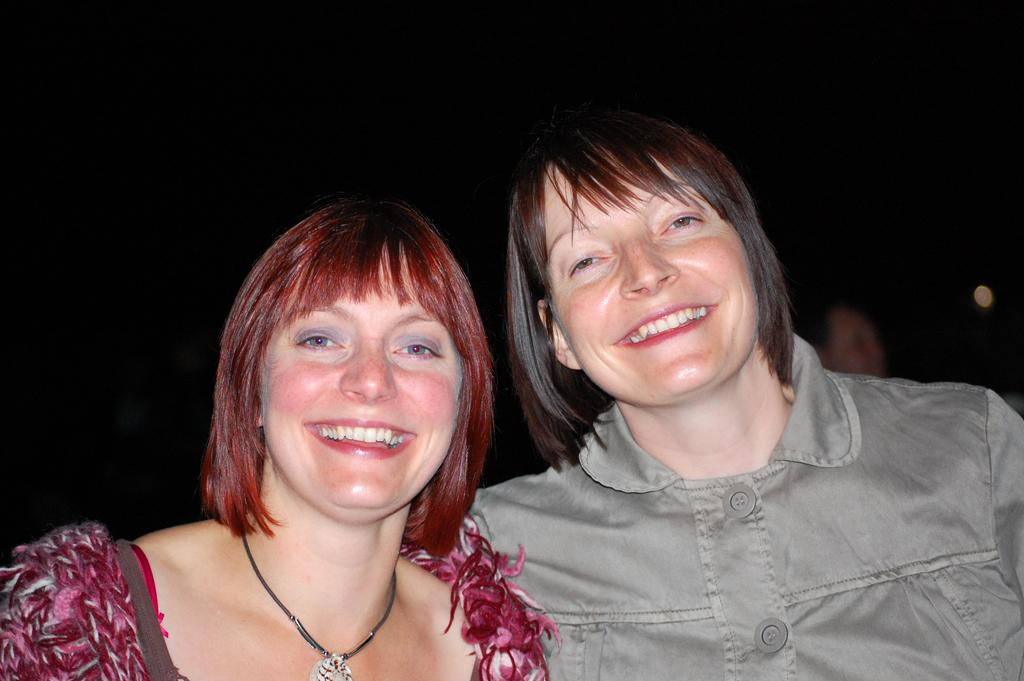How many people are in the image? There are two persons in the middle of the image, and another person on the right side of the image, but they are blurry. What are the two persons in the middle of the image doing? The two persons in the middle of the image are smiling. What type of toys can be seen in the hands of the blurry person on the right side of the image? There are no toys visible in the image, as the person on the right side is blurry and no toys are mentioned in the provided facts. 